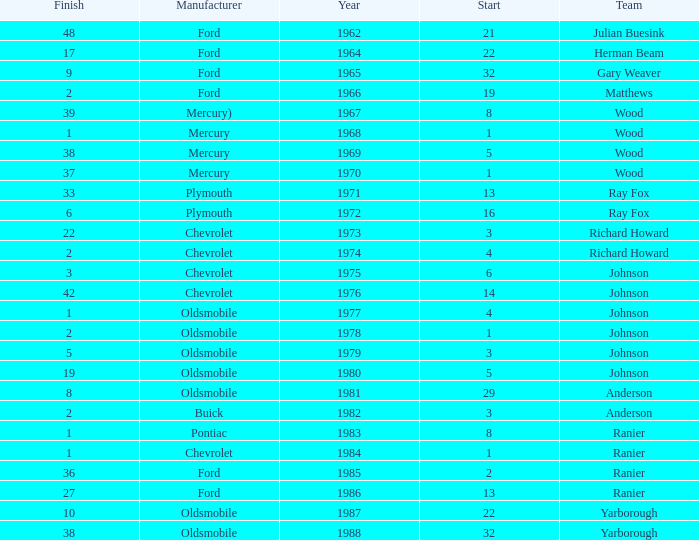What is the smallest finish time for a race after 1972 with a car manufactured by pontiac? 1.0. Give me the full table as a dictionary. {'header': ['Finish', 'Manufacturer', 'Year', 'Start', 'Team'], 'rows': [['48', 'Ford', '1962', '21', 'Julian Buesink'], ['17', 'Ford', '1964', '22', 'Herman Beam'], ['9', 'Ford', '1965', '32', 'Gary Weaver'], ['2', 'Ford', '1966', '19', 'Matthews'], ['39', 'Mercury)', '1967', '8', 'Wood'], ['1', 'Mercury', '1968', '1', 'Wood'], ['38', 'Mercury', '1969', '5', 'Wood'], ['37', 'Mercury', '1970', '1', 'Wood'], ['33', 'Plymouth', '1971', '13', 'Ray Fox'], ['6', 'Plymouth', '1972', '16', 'Ray Fox'], ['22', 'Chevrolet', '1973', '3', 'Richard Howard'], ['2', 'Chevrolet', '1974', '4', 'Richard Howard'], ['3', 'Chevrolet', '1975', '6', 'Johnson'], ['42', 'Chevrolet', '1976', '14', 'Johnson'], ['1', 'Oldsmobile', '1977', '4', 'Johnson'], ['2', 'Oldsmobile', '1978', '1', 'Johnson'], ['5', 'Oldsmobile', '1979', '3', 'Johnson'], ['19', 'Oldsmobile', '1980', '5', 'Johnson'], ['8', 'Oldsmobile', '1981', '29', 'Anderson'], ['2', 'Buick', '1982', '3', 'Anderson'], ['1', 'Pontiac', '1983', '8', 'Ranier'], ['1', 'Chevrolet', '1984', '1', 'Ranier'], ['36', 'Ford', '1985', '2', 'Ranier'], ['27', 'Ford', '1986', '13', 'Ranier'], ['10', 'Oldsmobile', '1987', '22', 'Yarborough'], ['38', 'Oldsmobile', '1988', '32', 'Yarborough']]} 